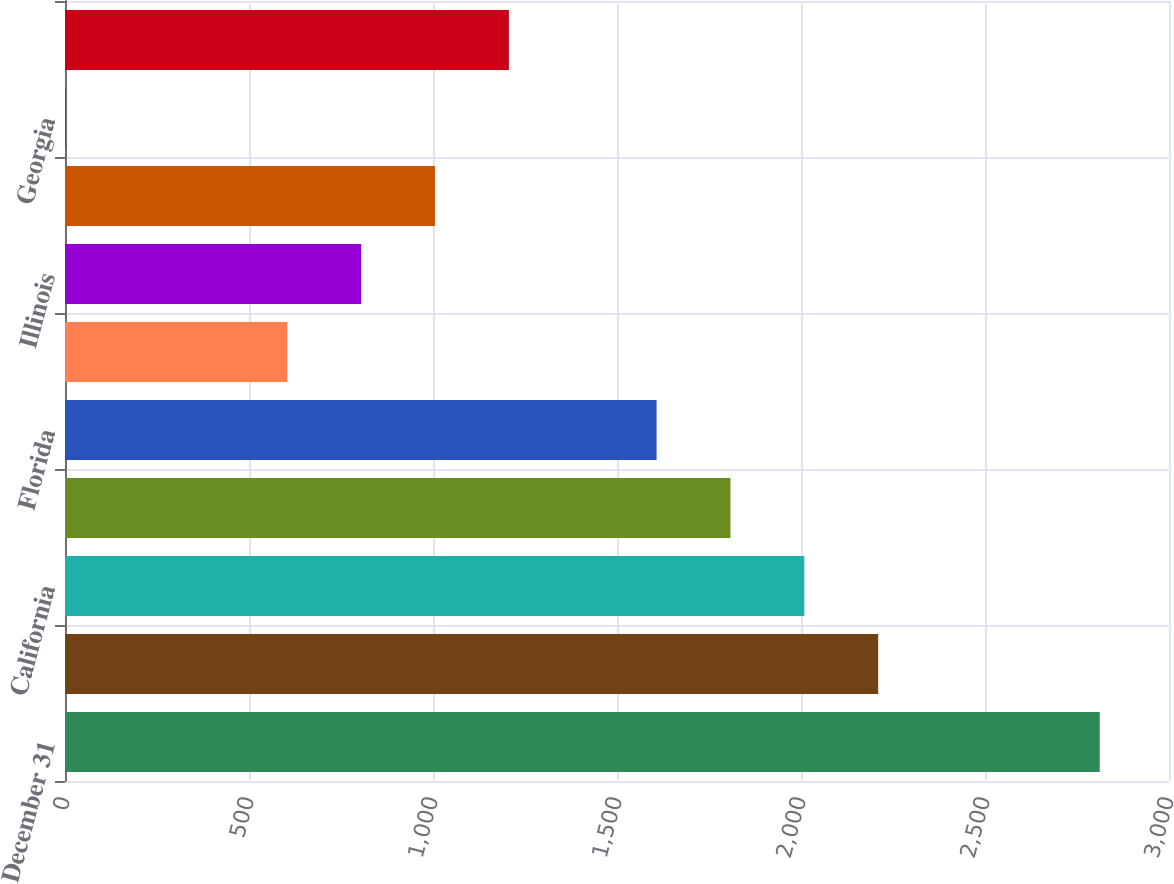<chart> <loc_0><loc_0><loc_500><loc_500><bar_chart><fcel>December 31<fcel>New York<fcel>California<fcel>Texas<fcel>Florida<fcel>Virginia<fcel>Illinois<fcel>New Jersey<fcel>Georgia<fcel>Maryland<nl><fcel>2811.8<fcel>2209.7<fcel>2009<fcel>1808.3<fcel>1607.6<fcel>604.1<fcel>804.8<fcel>1005.5<fcel>2<fcel>1206.2<nl></chart> 